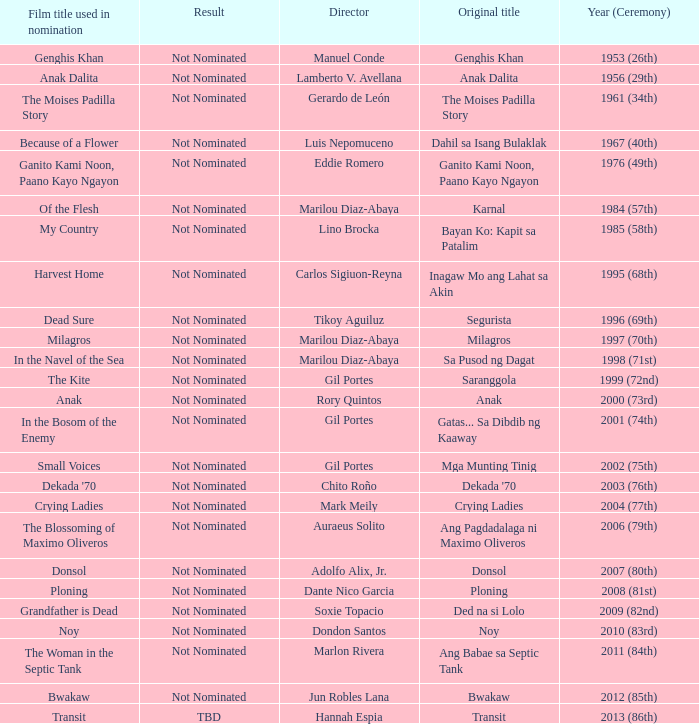What is the year when not nominated was the result, and In the Navel of the Sea was the film title used in nomination? 1998 (71st). 